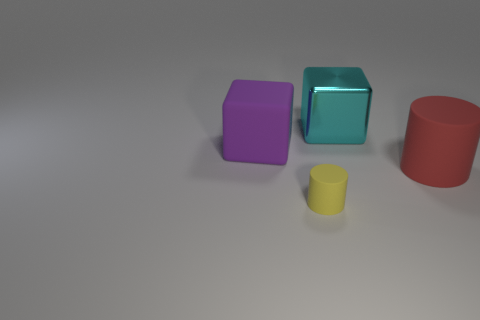Add 4 large purple matte blocks. How many objects exist? 8 Subtract 0 green cylinders. How many objects are left? 4 Subtract all cyan things. Subtract all big cyan metallic things. How many objects are left? 2 Add 4 large purple cubes. How many large purple cubes are left? 5 Add 4 red matte cylinders. How many red matte cylinders exist? 5 